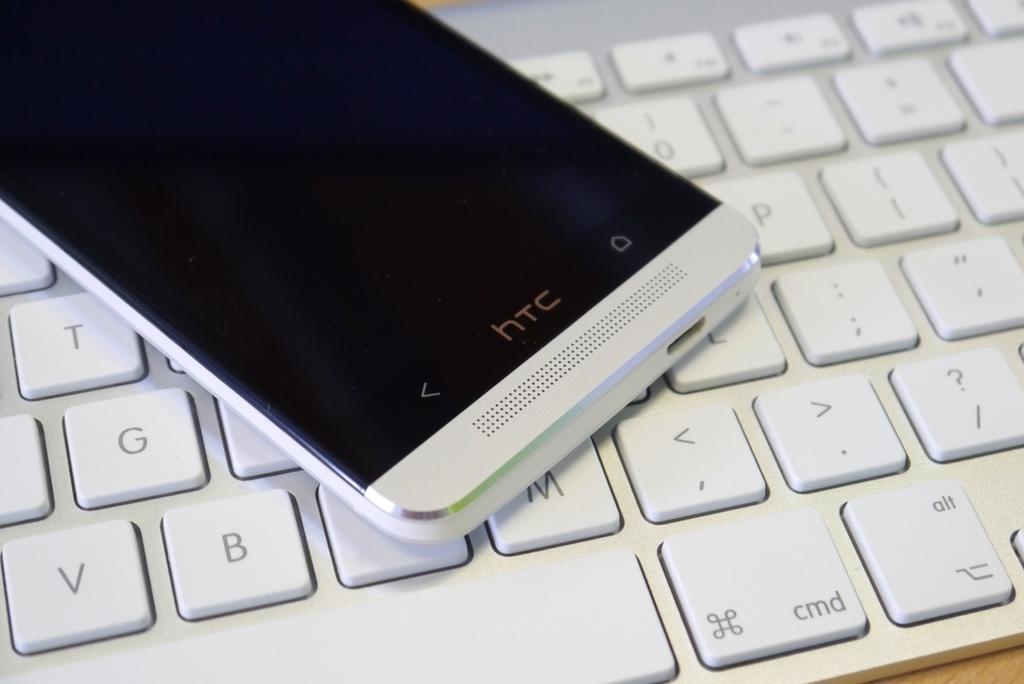Describe this image in one or two sentences. This picture shows a mobile phone and a keyboard on the table both are white in color. 